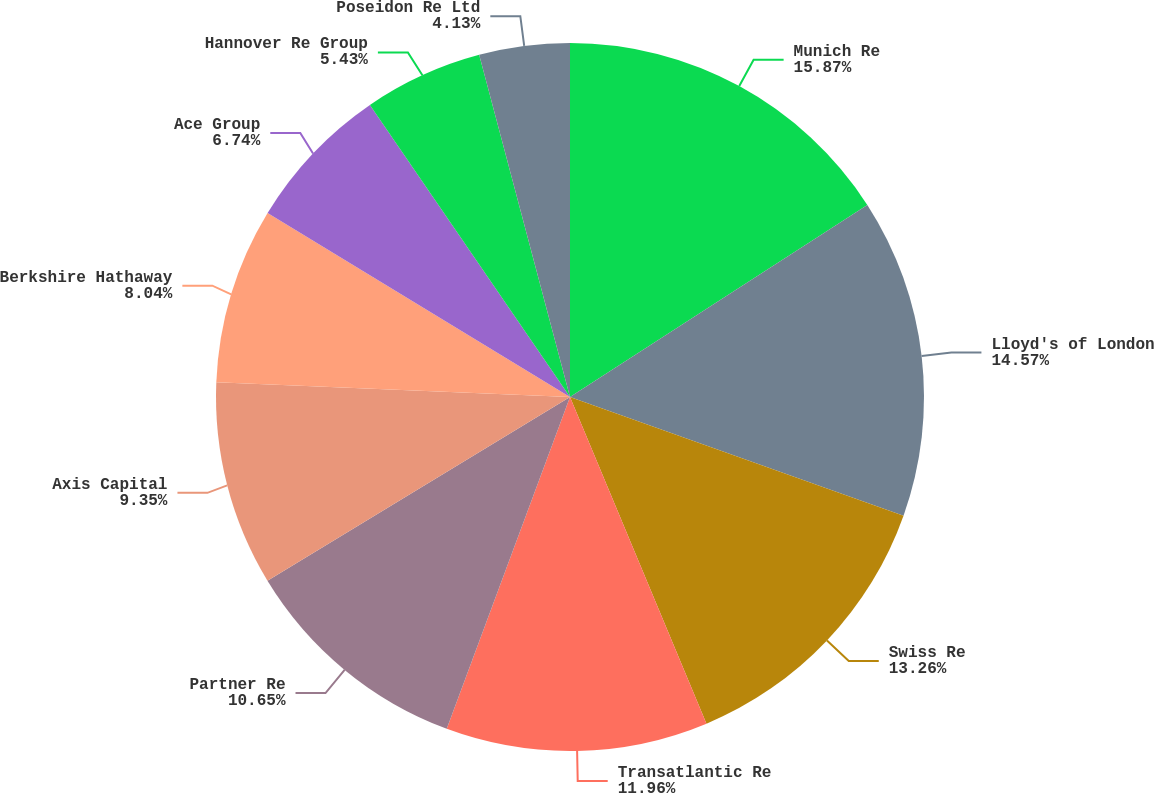Convert chart. <chart><loc_0><loc_0><loc_500><loc_500><pie_chart><fcel>Munich Re<fcel>Lloyd's of London<fcel>Swiss Re<fcel>Transatlantic Re<fcel>Partner Re<fcel>Axis Capital<fcel>Berkshire Hathaway<fcel>Ace Group<fcel>Hannover Re Group<fcel>Poseidon Re Ltd<nl><fcel>15.87%<fcel>14.57%<fcel>13.26%<fcel>11.96%<fcel>10.65%<fcel>9.35%<fcel>8.04%<fcel>6.74%<fcel>5.43%<fcel>4.13%<nl></chart> 